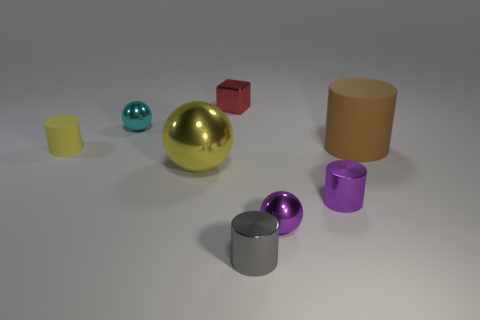Subtract all yellow cylinders. How many cylinders are left? 3 Add 1 small blue shiny cylinders. How many objects exist? 9 Subtract all yellow cylinders. How many cylinders are left? 3 Subtract all blocks. How many objects are left? 7 Subtract 2 cylinders. How many cylinders are left? 2 Add 5 red shiny cubes. How many red shiny cubes exist? 6 Subtract 0 green spheres. How many objects are left? 8 Subtract all red cylinders. Subtract all red cubes. How many cylinders are left? 4 Subtract all red shiny things. Subtract all small yellow things. How many objects are left? 6 Add 1 yellow rubber cylinders. How many yellow rubber cylinders are left? 2 